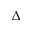Convert formula to latex. <formula><loc_0><loc_0><loc_500><loc_500>\Delta</formula> 